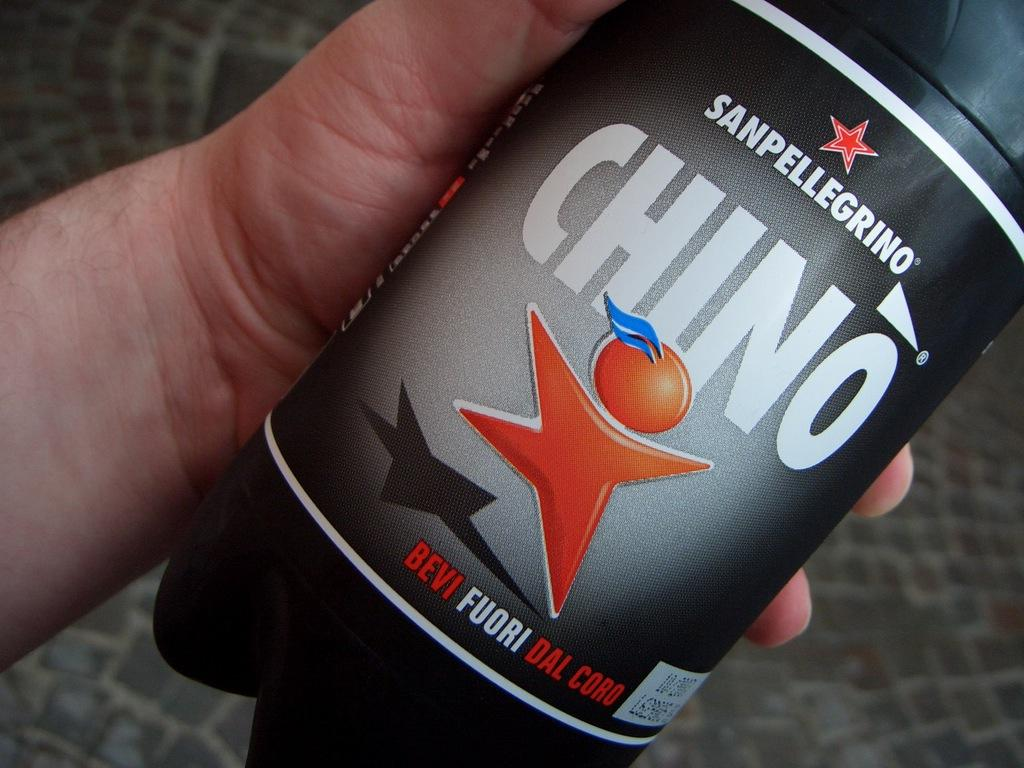Provide a one-sentence caption for the provided image. A bottle of a drink called Sanpellegrino Chino. 